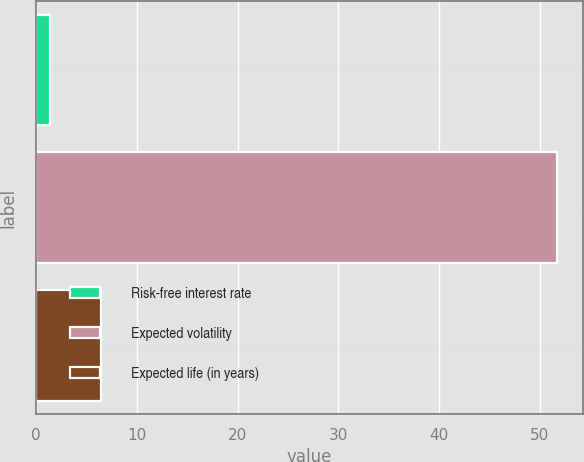Convert chart. <chart><loc_0><loc_0><loc_500><loc_500><bar_chart><fcel>Risk-free interest rate<fcel>Expected volatility<fcel>Expected life (in years)<nl><fcel>1.41<fcel>51.69<fcel>6.44<nl></chart> 